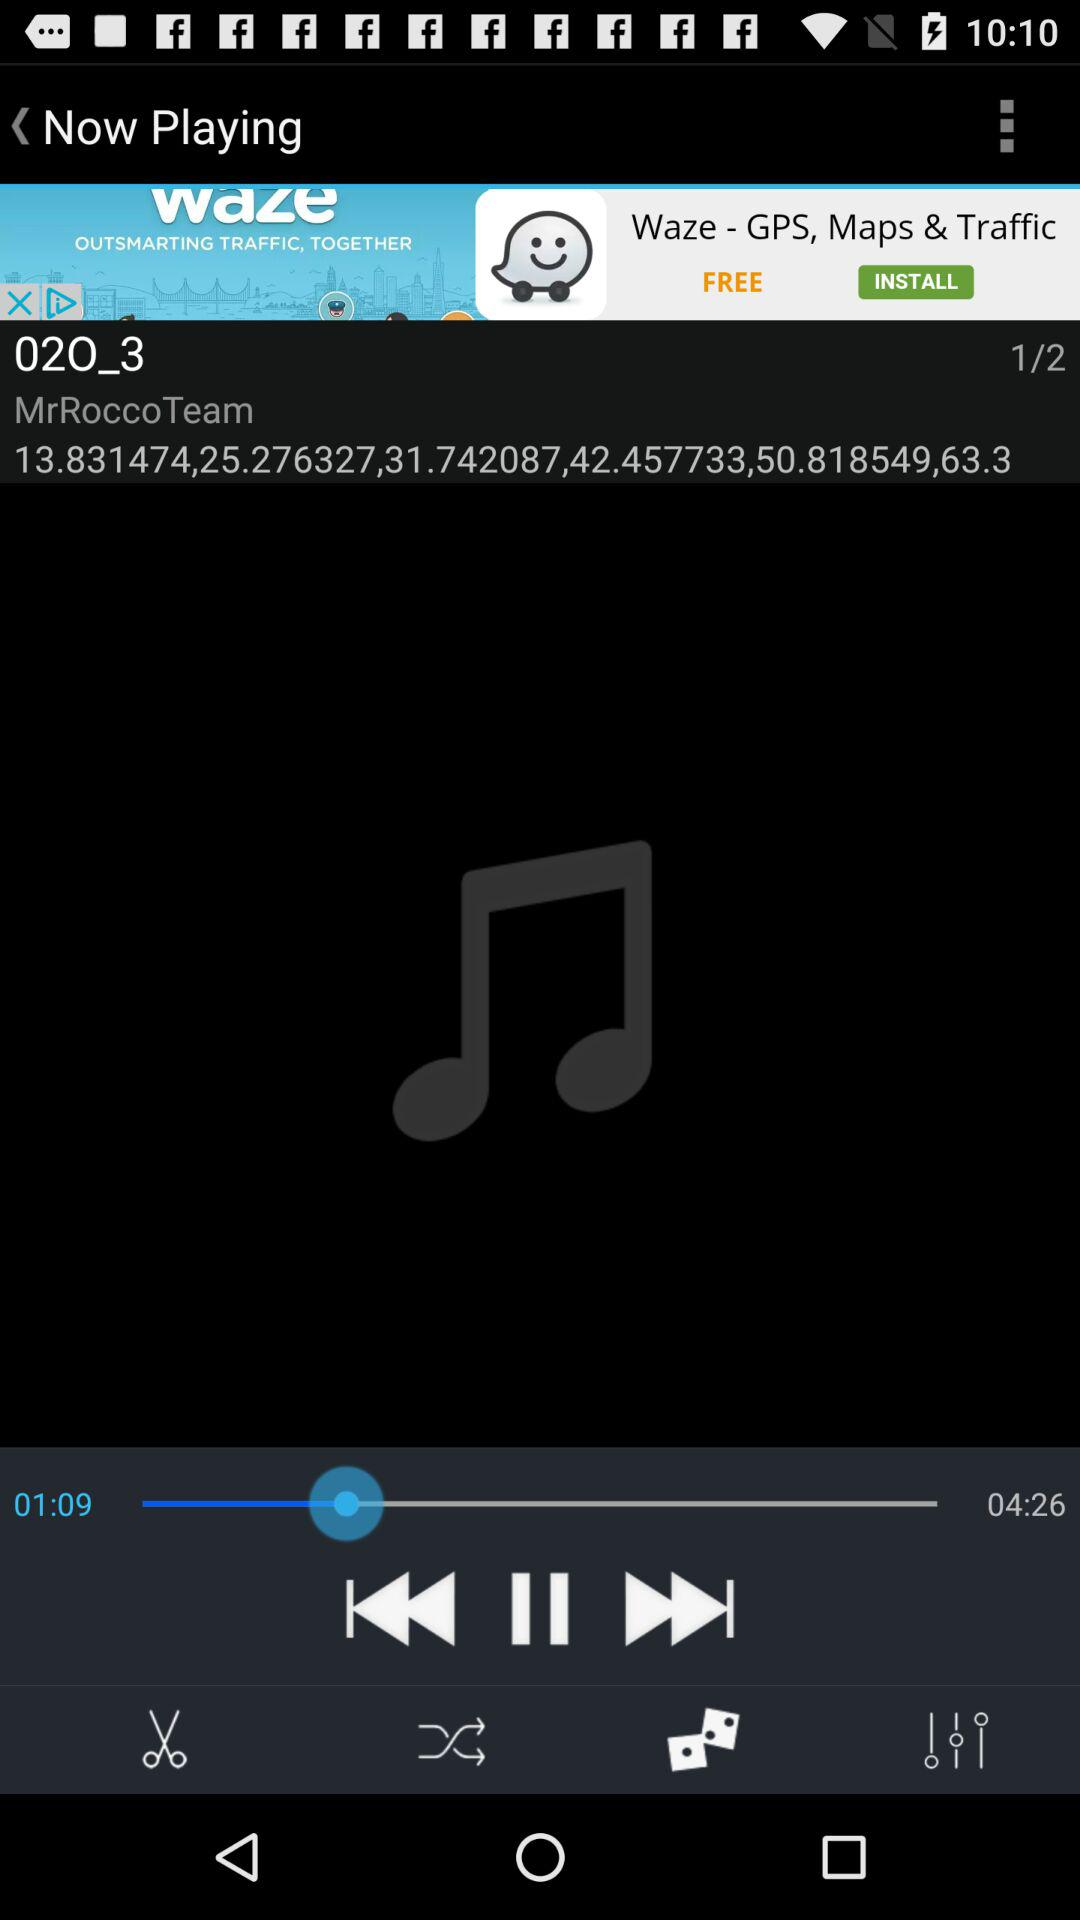What is the total number of songs? The total number of songs is 2. 